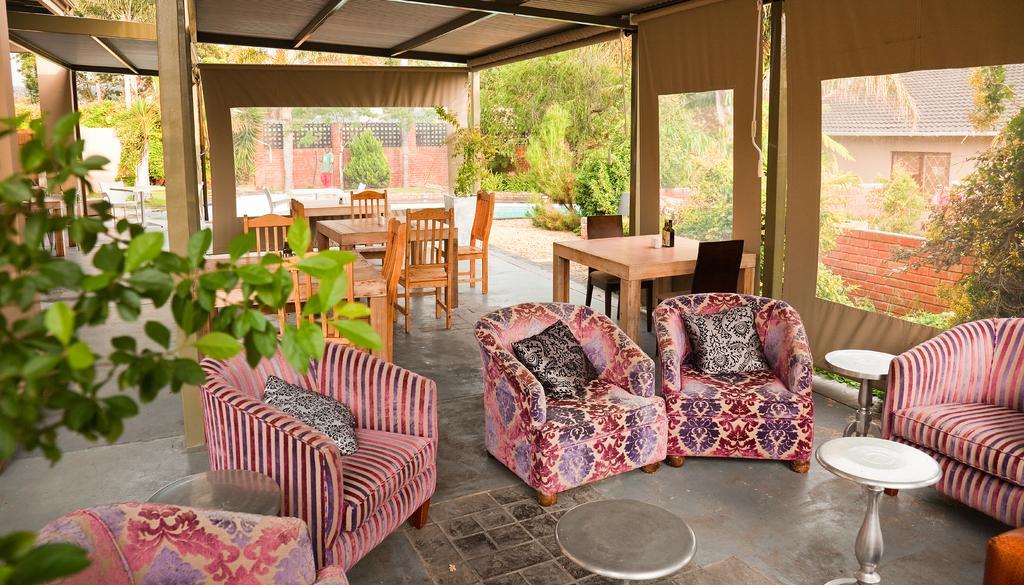Describe this image in one or two sentences. On the background we can see wall with bricks. Here we can see a house with window. Here we can see a person standing. Near to the house we can see trees and plants. Here we can see empty chairs with pillows and table. Here we can see wooden chairs and tables. 